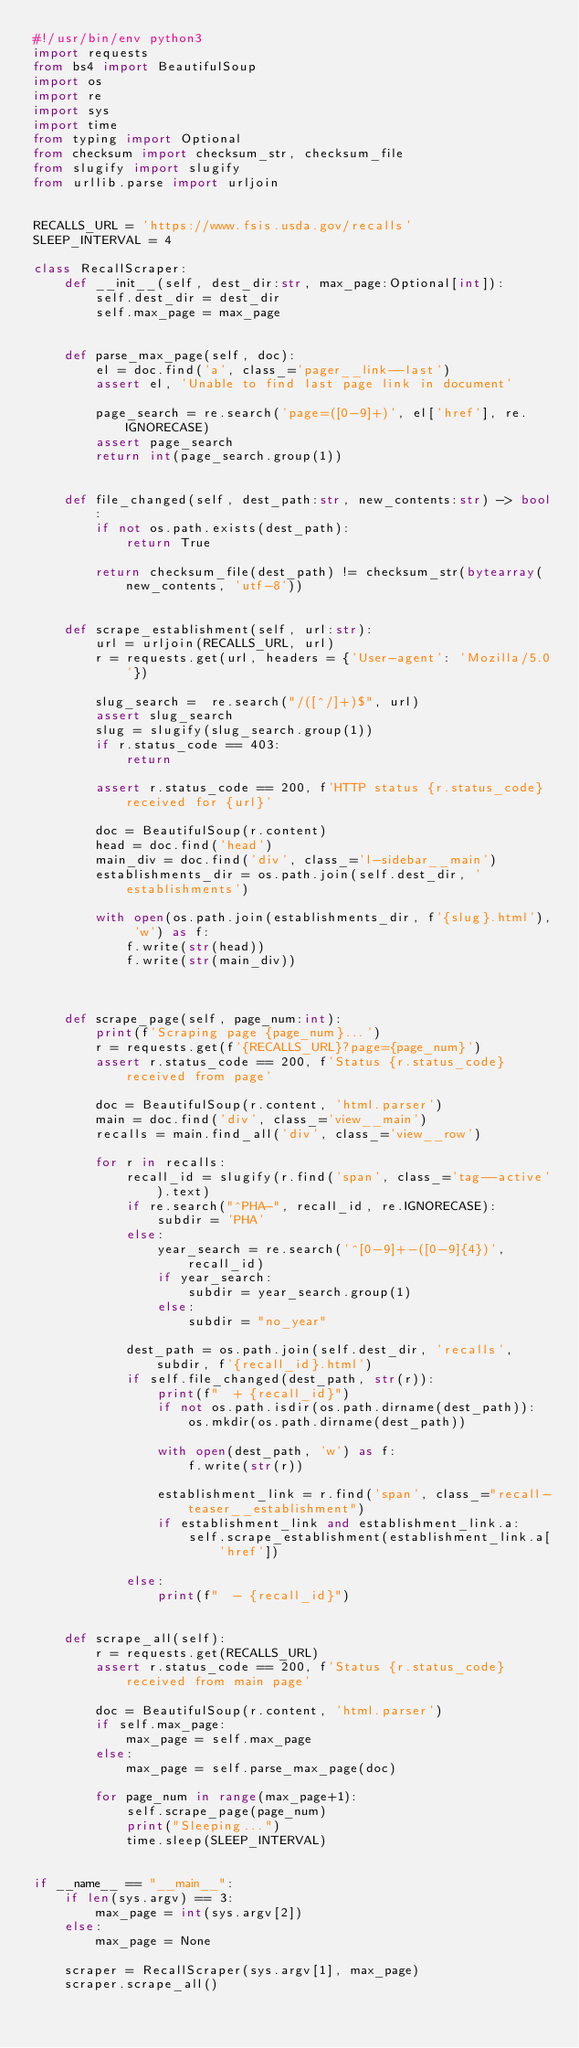Convert code to text. <code><loc_0><loc_0><loc_500><loc_500><_Python_>#!/usr/bin/env python3
import requests
from bs4 import BeautifulSoup
import os
import re
import sys
import time
from typing import Optional
from checksum import checksum_str, checksum_file
from slugify import slugify
from urllib.parse import urljoin


RECALLS_URL = 'https://www.fsis.usda.gov/recalls'
SLEEP_INTERVAL = 4

class RecallScraper:
    def __init__(self, dest_dir:str, max_page:Optional[int]):
        self.dest_dir = dest_dir
        self.max_page = max_page


    def parse_max_page(self, doc):
        el = doc.find('a', class_='pager__link--last')
        assert el, 'Unable to find last page link in document'

        page_search = re.search('page=([0-9]+)', el['href'], re.IGNORECASE)
        assert page_search
        return int(page_search.group(1))


    def file_changed(self, dest_path:str, new_contents:str) -> bool:
        if not os.path.exists(dest_path):
            return True

        return checksum_file(dest_path) != checksum_str(bytearray(new_contents, 'utf-8'))


    def scrape_establishment(self, url:str):
        url = urljoin(RECALLS_URL, url)
        r = requests.get(url, headers = {'User-agent': 'Mozilla/5.0'})

        slug_search =  re.search("/([^/]+)$", url)
        assert slug_search
        slug = slugify(slug_search.group(1))
        if r.status_code == 403:
            return

        assert r.status_code == 200, f'HTTP status {r.status_code} received for {url}'

        doc = BeautifulSoup(r.content)
        head = doc.find('head')
        main_div = doc.find('div', class_='l-sidebar__main')
        establishments_dir = os.path.join(self.dest_dir, 'establishments')

        with open(os.path.join(establishments_dir, f'{slug}.html'), 'w') as f:
            f.write(str(head))
            f.write(str(main_div))


    
    def scrape_page(self, page_num:int):
        print(f'Scraping page {page_num}...')
        r = requests.get(f'{RECALLS_URL}?page={page_num}')
        assert r.status_code == 200, f'Status {r.status_code} received from page'

        doc = BeautifulSoup(r.content, 'html.parser')
        main = doc.find('div', class_='view__main')
        recalls = main.find_all('div', class_='view__row')

        for r in recalls:
            recall_id = slugify(r.find('span', class_='tag--active').text)
            if re.search("^PHA-", recall_id, re.IGNORECASE):
                subdir = 'PHA'
            else:
                year_search = re.search('^[0-9]+-([0-9]{4})', recall_id)
                if year_search:
                    subdir = year_search.group(1)
                else:
                    subdir = "no_year"

            dest_path = os.path.join(self.dest_dir, 'recalls', subdir, f'{recall_id}.html')
            if self.file_changed(dest_path, str(r)):
                print(f"  + {recall_id}")
                if not os.path.isdir(os.path.dirname(dest_path)):
                    os.mkdir(os.path.dirname(dest_path))

                with open(dest_path, 'w') as f:
                    f.write(str(r))

                establishment_link = r.find('span', class_="recall-teaser__establishment")
                if establishment_link and establishment_link.a:
                    self.scrape_establishment(establishment_link.a['href'])

            else:
                print(f"  - {recall_id}")

    
    def scrape_all(self):
        r = requests.get(RECALLS_URL)
        assert r.status_code == 200, f'Status {r.status_code} received from main page'

        doc = BeautifulSoup(r.content, 'html.parser')
        if self.max_page:
            max_page = self.max_page
        else:
            max_page = self.parse_max_page(doc)

        for page_num in range(max_page+1):
            self.scrape_page(page_num)
            print("Sleeping...")
            time.sleep(SLEEP_INTERVAL)


if __name__ == "__main__":
    if len(sys.argv) == 3:
        max_page = int(sys.argv[2])
    else:
        max_page = None

    scraper = RecallScraper(sys.argv[1], max_page)
    scraper.scrape_all()
</code> 